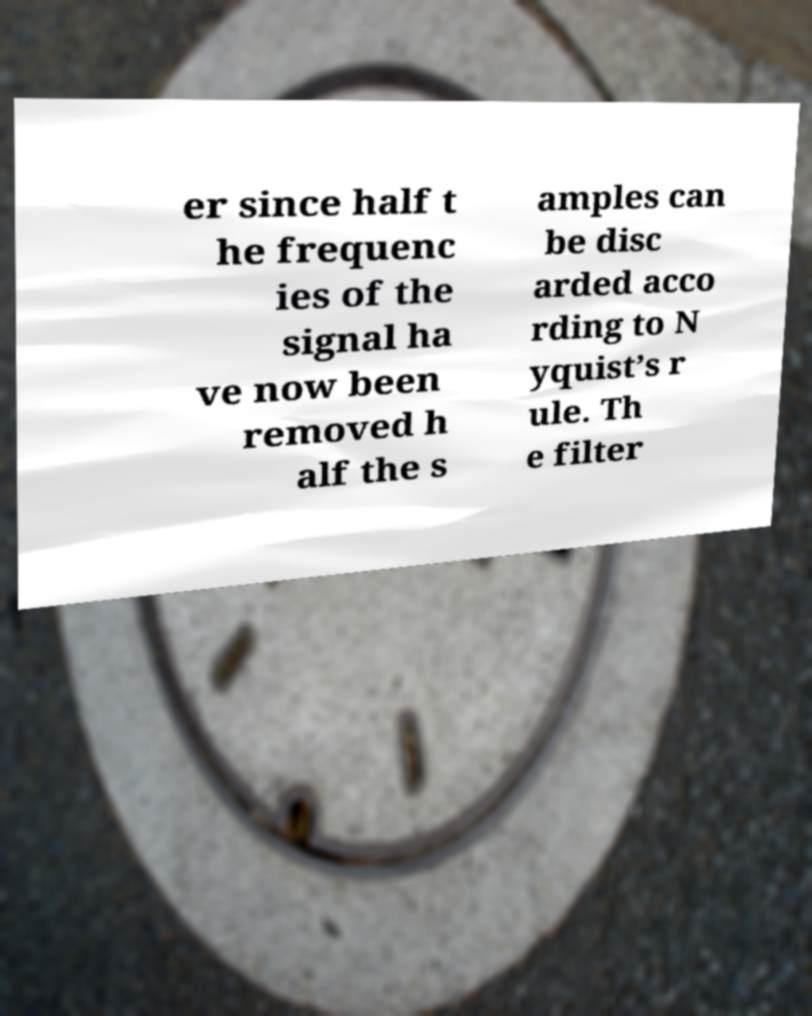Can you accurately transcribe the text from the provided image for me? er since half t he frequenc ies of the signal ha ve now been removed h alf the s amples can be disc arded acco rding to N yquist’s r ule. Th e filter 